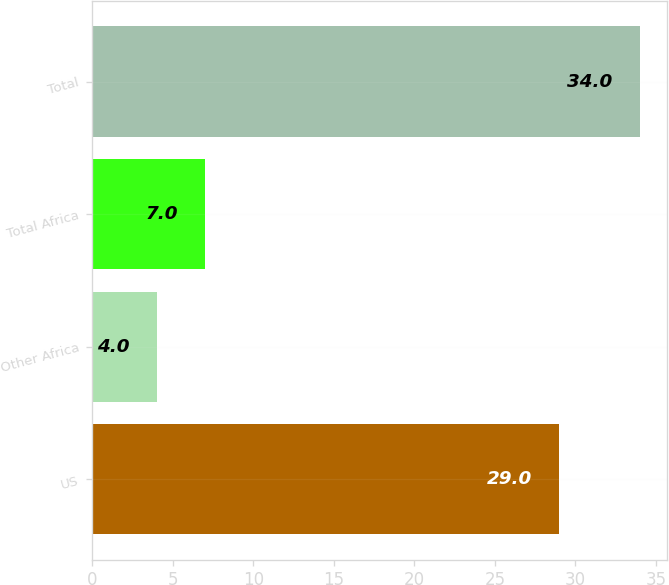<chart> <loc_0><loc_0><loc_500><loc_500><bar_chart><fcel>US<fcel>Other Africa<fcel>Total Africa<fcel>Total<nl><fcel>29<fcel>4<fcel>7<fcel>34<nl></chart> 